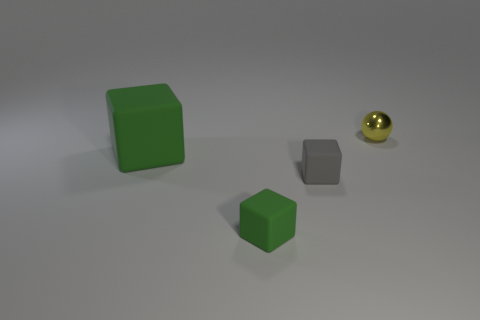Are there any other things that have the same material as the small yellow sphere?
Give a very brief answer. No. What material is the ball that is the same size as the gray rubber thing?
Give a very brief answer. Metal. What number of blocks are the same color as the large thing?
Provide a short and direct response. 1. Are the small cube that is in front of the small gray matte cube and the gray block made of the same material?
Your answer should be compact. Yes. There is a rubber object that is left of the tiny gray rubber block and behind the tiny green cube; what size is it?
Offer a terse response. Large. How big is the rubber object in front of the tiny gray cube?
Give a very brief answer. Small. There is a small rubber object that is the same color as the big object; what shape is it?
Offer a very short reply. Cube. What shape is the small object behind the small rubber cube on the right side of the matte cube that is in front of the small gray block?
Ensure brevity in your answer.  Sphere. How many other things are there of the same shape as the yellow thing?
Provide a short and direct response. 0. How many metallic things are either small cubes or yellow spheres?
Provide a short and direct response. 1. 